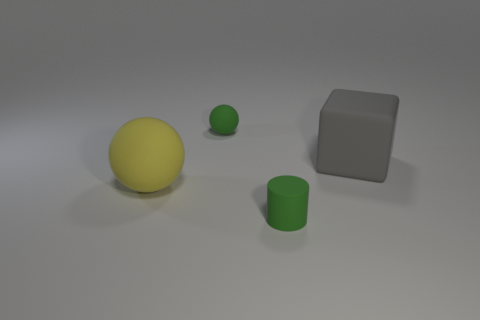Do the rubber sphere that is to the right of the yellow matte ball and the small rubber object in front of the green matte ball have the same color?
Give a very brief answer. Yes. Is there any other thing of the same color as the large block?
Your answer should be compact. No. There is a rubber thing in front of the yellow ball on the left side of the green rubber cylinder; what is its color?
Offer a terse response. Green. Is there a big red matte cylinder?
Provide a short and direct response. No. What is the color of the rubber thing that is both on the left side of the big gray block and behind the large yellow thing?
Offer a terse response. Green. Does the green thing behind the matte cylinder have the same size as the green thing in front of the big gray rubber block?
Your response must be concise. Yes. How many other objects are the same size as the yellow rubber ball?
Give a very brief answer. 1. How many rubber blocks are on the right side of the big thing left of the small rubber cylinder?
Your response must be concise. 1. Is the number of green rubber cylinders that are behind the big yellow ball less than the number of yellow rubber cylinders?
Provide a succinct answer. No. What is the shape of the big rubber thing that is on the left side of the tiny matte thing right of the green thing that is behind the green matte cylinder?
Offer a terse response. Sphere. 